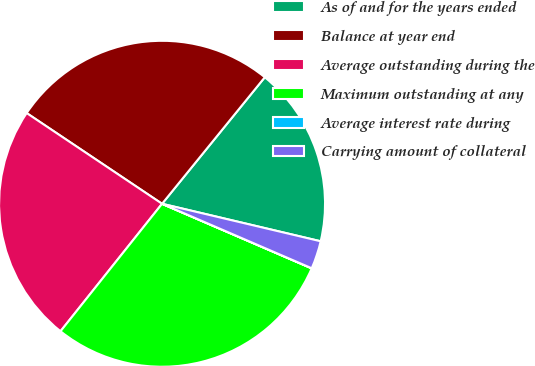Convert chart to OTSL. <chart><loc_0><loc_0><loc_500><loc_500><pie_chart><fcel>As of and for the years ended<fcel>Balance at year end<fcel>Average outstanding during the<fcel>Maximum outstanding at any<fcel>Average interest rate during<fcel>Carrying amount of collateral<nl><fcel>17.84%<fcel>26.46%<fcel>23.69%<fcel>29.22%<fcel>0.01%<fcel>2.78%<nl></chart> 